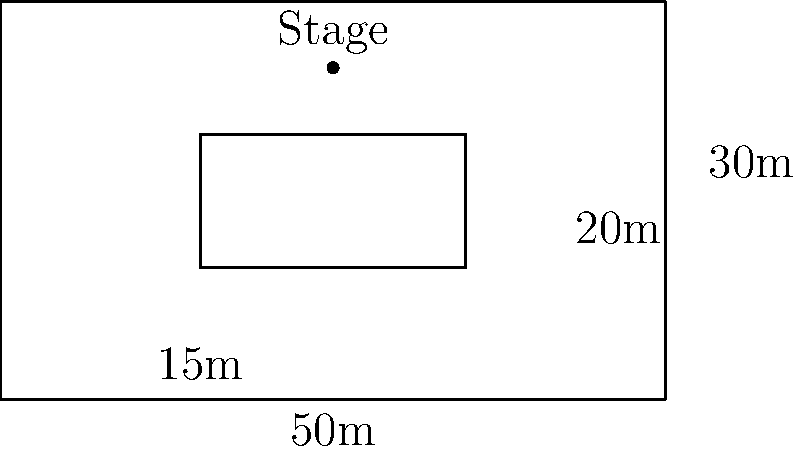As an event planner for a corporate conference, you're tasked with optimizing the seating arrangement in a rectangular hall. The hall measures 50m x 30m, with a central aisle of 15m x 20m. If each attendee requires 1 square meter of space, including walking areas, what is the maximum number of attendees that can be accommodated while maintaining the central aisle? To solve this problem, we'll follow these steps:

1. Calculate the total area of the hall:
   $A_{total} = 50m \times 30m = 1500m^2$

2. Calculate the area of the central aisle:
   $A_{aisle} = 15m \times 20m = 300m^2$

3. Calculate the available seating area:
   $A_{seating} = A_{total} - A_{aisle} = 1500m^2 - 300m^2 = 1200m^2$

4. Since each attendee requires 1 square meter of space, including walking areas, the maximum number of attendees that can be accommodated is equal to the available seating area in square meters.

Therefore, the maximum number of attendees = $1200$

This arrangement ensures that the central aisle is maintained for easy movement and access to different parts of the conference hall, while maximizing the seating capacity for the corporate event.
Answer: 1200 attendees 